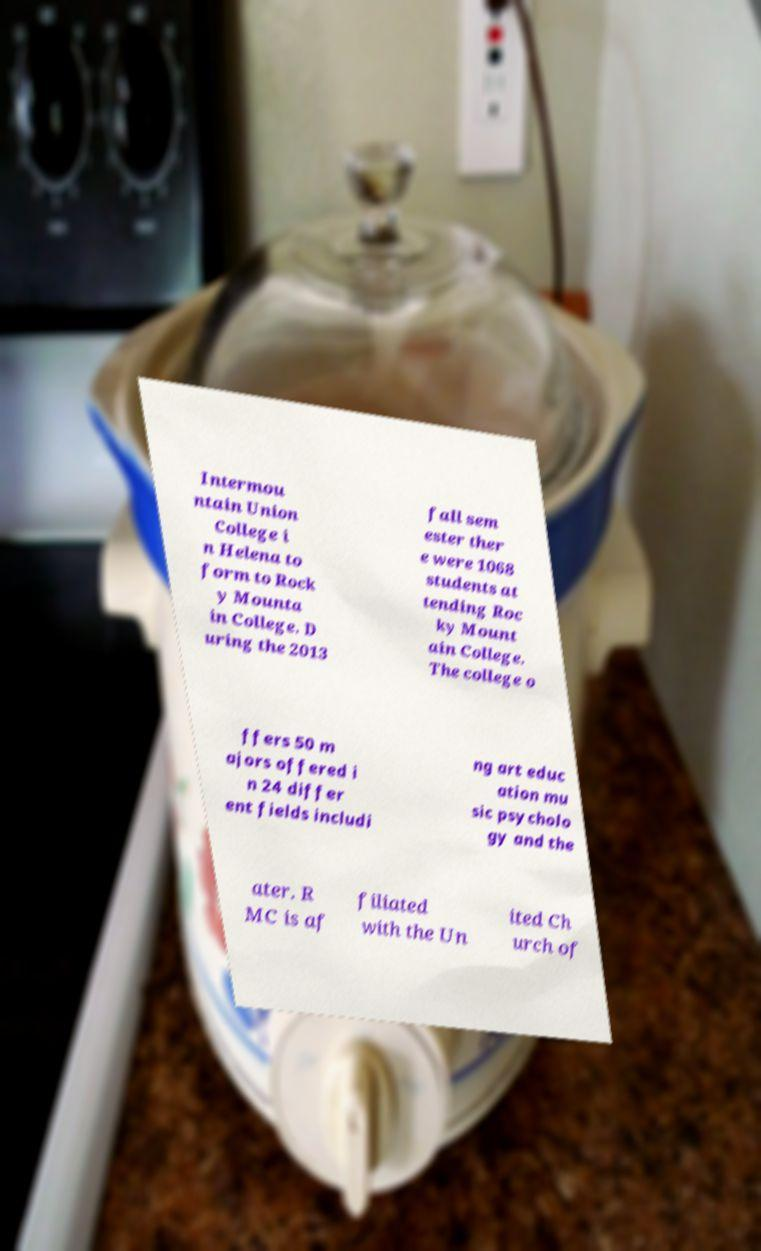There's text embedded in this image that I need extracted. Can you transcribe it verbatim? Intermou ntain Union College i n Helena to form to Rock y Mounta in College. D uring the 2013 fall sem ester ther e were 1068 students at tending Roc ky Mount ain College. The college o ffers 50 m ajors offered i n 24 differ ent fields includi ng art educ ation mu sic psycholo gy and the ater. R MC is af filiated with the Un ited Ch urch of 